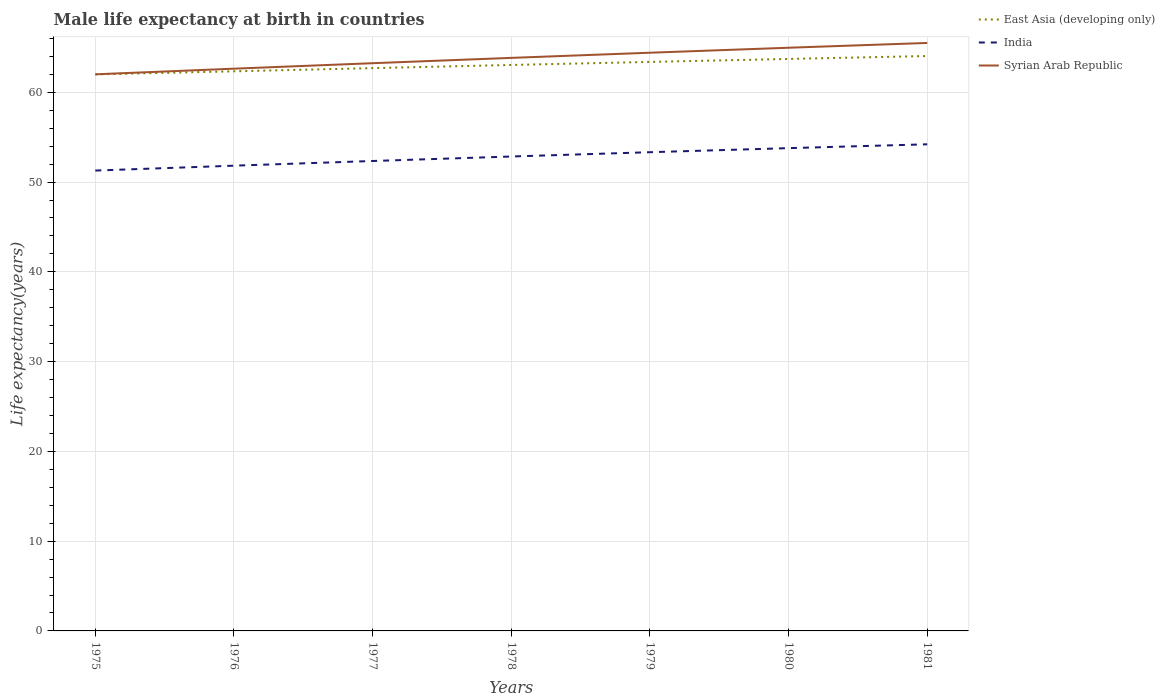How many different coloured lines are there?
Your answer should be compact. 3. Is the number of lines equal to the number of legend labels?
Provide a succinct answer. Yes. Across all years, what is the maximum male life expectancy at birth in India?
Your answer should be very brief. 51.28. In which year was the male life expectancy at birth in Syrian Arab Republic maximum?
Make the answer very short. 1975. What is the total male life expectancy at birth in Syrian Arab Republic in the graph?
Provide a succinct answer. -0.59. What is the difference between the highest and the second highest male life expectancy at birth in Syrian Arab Republic?
Your answer should be very brief. 3.49. Is the male life expectancy at birth in Syrian Arab Republic strictly greater than the male life expectancy at birth in India over the years?
Give a very brief answer. No. Are the values on the major ticks of Y-axis written in scientific E-notation?
Offer a very short reply. No. How many legend labels are there?
Give a very brief answer. 3. How are the legend labels stacked?
Your answer should be compact. Vertical. What is the title of the graph?
Ensure brevity in your answer.  Male life expectancy at birth in countries. Does "World" appear as one of the legend labels in the graph?
Provide a short and direct response. No. What is the label or title of the Y-axis?
Provide a short and direct response. Life expectancy(years). What is the Life expectancy(years) of East Asia (developing only) in 1975?
Your answer should be compact. 62. What is the Life expectancy(years) in India in 1975?
Provide a succinct answer. 51.28. What is the Life expectancy(years) of Syrian Arab Republic in 1975?
Offer a very short reply. 62.01. What is the Life expectancy(years) in East Asia (developing only) in 1976?
Keep it short and to the point. 62.34. What is the Life expectancy(years) of India in 1976?
Keep it short and to the point. 51.83. What is the Life expectancy(years) of Syrian Arab Republic in 1976?
Offer a very short reply. 62.63. What is the Life expectancy(years) in East Asia (developing only) in 1977?
Offer a terse response. 62.7. What is the Life expectancy(years) in India in 1977?
Provide a short and direct response. 52.35. What is the Life expectancy(years) in Syrian Arab Republic in 1977?
Ensure brevity in your answer.  63.24. What is the Life expectancy(years) of East Asia (developing only) in 1978?
Your answer should be compact. 63.05. What is the Life expectancy(years) in India in 1978?
Offer a terse response. 52.85. What is the Life expectancy(years) of Syrian Arab Republic in 1978?
Provide a short and direct response. 63.84. What is the Life expectancy(years) in East Asia (developing only) in 1979?
Your answer should be very brief. 63.39. What is the Life expectancy(years) in India in 1979?
Make the answer very short. 53.33. What is the Life expectancy(years) in Syrian Arab Republic in 1979?
Offer a terse response. 64.41. What is the Life expectancy(years) in East Asia (developing only) in 1980?
Make the answer very short. 63.72. What is the Life expectancy(years) of India in 1980?
Provide a succinct answer. 53.78. What is the Life expectancy(years) in Syrian Arab Republic in 1980?
Offer a terse response. 64.97. What is the Life expectancy(years) in East Asia (developing only) in 1981?
Your answer should be very brief. 64.04. What is the Life expectancy(years) in India in 1981?
Your response must be concise. 54.21. What is the Life expectancy(years) of Syrian Arab Republic in 1981?
Your answer should be very brief. 65.5. Across all years, what is the maximum Life expectancy(years) in East Asia (developing only)?
Your answer should be very brief. 64.04. Across all years, what is the maximum Life expectancy(years) in India?
Your answer should be very brief. 54.21. Across all years, what is the maximum Life expectancy(years) of Syrian Arab Republic?
Offer a very short reply. 65.5. Across all years, what is the minimum Life expectancy(years) of East Asia (developing only)?
Provide a succinct answer. 62. Across all years, what is the minimum Life expectancy(years) in India?
Give a very brief answer. 51.28. Across all years, what is the minimum Life expectancy(years) of Syrian Arab Republic?
Offer a very short reply. 62.01. What is the total Life expectancy(years) of East Asia (developing only) in the graph?
Your answer should be compact. 441.23. What is the total Life expectancy(years) in India in the graph?
Offer a terse response. 369.63. What is the total Life expectancy(years) of Syrian Arab Republic in the graph?
Make the answer very short. 446.6. What is the difference between the Life expectancy(years) in East Asia (developing only) in 1975 and that in 1976?
Offer a terse response. -0.34. What is the difference between the Life expectancy(years) in India in 1975 and that in 1976?
Offer a terse response. -0.54. What is the difference between the Life expectancy(years) of Syrian Arab Republic in 1975 and that in 1976?
Your response must be concise. -0.63. What is the difference between the Life expectancy(years) in East Asia (developing only) in 1975 and that in 1977?
Provide a short and direct response. -0.7. What is the difference between the Life expectancy(years) of India in 1975 and that in 1977?
Your answer should be compact. -1.06. What is the difference between the Life expectancy(years) of Syrian Arab Republic in 1975 and that in 1977?
Offer a very short reply. -1.24. What is the difference between the Life expectancy(years) of East Asia (developing only) in 1975 and that in 1978?
Your answer should be very brief. -1.05. What is the difference between the Life expectancy(years) in India in 1975 and that in 1978?
Give a very brief answer. -1.56. What is the difference between the Life expectancy(years) in Syrian Arab Republic in 1975 and that in 1978?
Your answer should be very brief. -1.83. What is the difference between the Life expectancy(years) in East Asia (developing only) in 1975 and that in 1979?
Offer a terse response. -1.39. What is the difference between the Life expectancy(years) of India in 1975 and that in 1979?
Your answer should be very brief. -2.04. What is the difference between the Life expectancy(years) of Syrian Arab Republic in 1975 and that in 1979?
Ensure brevity in your answer.  -2.41. What is the difference between the Life expectancy(years) of East Asia (developing only) in 1975 and that in 1980?
Offer a very short reply. -1.72. What is the difference between the Life expectancy(years) in India in 1975 and that in 1980?
Give a very brief answer. -2.5. What is the difference between the Life expectancy(years) of Syrian Arab Republic in 1975 and that in 1980?
Offer a very short reply. -2.96. What is the difference between the Life expectancy(years) in East Asia (developing only) in 1975 and that in 1981?
Make the answer very short. -2.05. What is the difference between the Life expectancy(years) in India in 1975 and that in 1981?
Offer a terse response. -2.92. What is the difference between the Life expectancy(years) in Syrian Arab Republic in 1975 and that in 1981?
Your response must be concise. -3.49. What is the difference between the Life expectancy(years) in East Asia (developing only) in 1976 and that in 1977?
Give a very brief answer. -0.36. What is the difference between the Life expectancy(years) in India in 1976 and that in 1977?
Your answer should be very brief. -0.52. What is the difference between the Life expectancy(years) of Syrian Arab Republic in 1976 and that in 1977?
Keep it short and to the point. -0.61. What is the difference between the Life expectancy(years) of East Asia (developing only) in 1976 and that in 1978?
Your response must be concise. -0.71. What is the difference between the Life expectancy(years) of India in 1976 and that in 1978?
Your answer should be very brief. -1.02. What is the difference between the Life expectancy(years) of Syrian Arab Republic in 1976 and that in 1978?
Provide a succinct answer. -1.2. What is the difference between the Life expectancy(years) in East Asia (developing only) in 1976 and that in 1979?
Make the answer very short. -1.05. What is the difference between the Life expectancy(years) in India in 1976 and that in 1979?
Make the answer very short. -1.5. What is the difference between the Life expectancy(years) of Syrian Arab Republic in 1976 and that in 1979?
Provide a short and direct response. -1.78. What is the difference between the Life expectancy(years) in East Asia (developing only) in 1976 and that in 1980?
Make the answer very short. -1.38. What is the difference between the Life expectancy(years) of India in 1976 and that in 1980?
Give a very brief answer. -1.96. What is the difference between the Life expectancy(years) in Syrian Arab Republic in 1976 and that in 1980?
Provide a succinct answer. -2.33. What is the difference between the Life expectancy(years) in East Asia (developing only) in 1976 and that in 1981?
Offer a very short reply. -1.7. What is the difference between the Life expectancy(years) of India in 1976 and that in 1981?
Your answer should be compact. -2.38. What is the difference between the Life expectancy(years) of Syrian Arab Republic in 1976 and that in 1981?
Offer a terse response. -2.87. What is the difference between the Life expectancy(years) of East Asia (developing only) in 1977 and that in 1978?
Your answer should be compact. -0.35. What is the difference between the Life expectancy(years) of India in 1977 and that in 1978?
Give a very brief answer. -0.5. What is the difference between the Life expectancy(years) of Syrian Arab Republic in 1977 and that in 1978?
Your response must be concise. -0.59. What is the difference between the Life expectancy(years) of East Asia (developing only) in 1977 and that in 1979?
Keep it short and to the point. -0.69. What is the difference between the Life expectancy(years) in India in 1977 and that in 1979?
Provide a short and direct response. -0.98. What is the difference between the Life expectancy(years) of Syrian Arab Republic in 1977 and that in 1979?
Your response must be concise. -1.17. What is the difference between the Life expectancy(years) of East Asia (developing only) in 1977 and that in 1980?
Your answer should be compact. -1.02. What is the difference between the Life expectancy(years) of India in 1977 and that in 1980?
Give a very brief answer. -1.43. What is the difference between the Life expectancy(years) in Syrian Arab Republic in 1977 and that in 1980?
Provide a succinct answer. -1.72. What is the difference between the Life expectancy(years) of East Asia (developing only) in 1977 and that in 1981?
Offer a terse response. -1.35. What is the difference between the Life expectancy(years) of India in 1977 and that in 1981?
Your answer should be very brief. -1.86. What is the difference between the Life expectancy(years) of Syrian Arab Republic in 1977 and that in 1981?
Offer a terse response. -2.26. What is the difference between the Life expectancy(years) in East Asia (developing only) in 1978 and that in 1979?
Give a very brief answer. -0.34. What is the difference between the Life expectancy(years) in India in 1978 and that in 1979?
Give a very brief answer. -0.48. What is the difference between the Life expectancy(years) in Syrian Arab Republic in 1978 and that in 1979?
Make the answer very short. -0.57. What is the difference between the Life expectancy(years) of East Asia (developing only) in 1978 and that in 1980?
Your answer should be very brief. -0.67. What is the difference between the Life expectancy(years) in India in 1978 and that in 1980?
Keep it short and to the point. -0.93. What is the difference between the Life expectancy(years) of Syrian Arab Republic in 1978 and that in 1980?
Offer a very short reply. -1.13. What is the difference between the Life expectancy(years) in East Asia (developing only) in 1978 and that in 1981?
Offer a very short reply. -1. What is the difference between the Life expectancy(years) of India in 1978 and that in 1981?
Your answer should be compact. -1.36. What is the difference between the Life expectancy(years) in Syrian Arab Republic in 1978 and that in 1981?
Offer a very short reply. -1.66. What is the difference between the Life expectancy(years) of East Asia (developing only) in 1979 and that in 1980?
Give a very brief answer. -0.33. What is the difference between the Life expectancy(years) of India in 1979 and that in 1980?
Your answer should be compact. -0.45. What is the difference between the Life expectancy(years) in Syrian Arab Republic in 1979 and that in 1980?
Make the answer very short. -0.56. What is the difference between the Life expectancy(years) of East Asia (developing only) in 1979 and that in 1981?
Your answer should be compact. -0.66. What is the difference between the Life expectancy(years) of India in 1979 and that in 1981?
Provide a succinct answer. -0.88. What is the difference between the Life expectancy(years) of Syrian Arab Republic in 1979 and that in 1981?
Ensure brevity in your answer.  -1.09. What is the difference between the Life expectancy(years) in East Asia (developing only) in 1980 and that in 1981?
Provide a succinct answer. -0.32. What is the difference between the Life expectancy(years) in India in 1980 and that in 1981?
Your response must be concise. -0.43. What is the difference between the Life expectancy(years) of Syrian Arab Republic in 1980 and that in 1981?
Provide a succinct answer. -0.53. What is the difference between the Life expectancy(years) of East Asia (developing only) in 1975 and the Life expectancy(years) of India in 1976?
Your answer should be very brief. 10.17. What is the difference between the Life expectancy(years) of East Asia (developing only) in 1975 and the Life expectancy(years) of Syrian Arab Republic in 1976?
Provide a short and direct response. -0.64. What is the difference between the Life expectancy(years) in India in 1975 and the Life expectancy(years) in Syrian Arab Republic in 1976?
Keep it short and to the point. -11.35. What is the difference between the Life expectancy(years) in East Asia (developing only) in 1975 and the Life expectancy(years) in India in 1977?
Make the answer very short. 9.65. What is the difference between the Life expectancy(years) in East Asia (developing only) in 1975 and the Life expectancy(years) in Syrian Arab Republic in 1977?
Provide a short and direct response. -1.25. What is the difference between the Life expectancy(years) of India in 1975 and the Life expectancy(years) of Syrian Arab Republic in 1977?
Your response must be concise. -11.96. What is the difference between the Life expectancy(years) of East Asia (developing only) in 1975 and the Life expectancy(years) of India in 1978?
Give a very brief answer. 9.15. What is the difference between the Life expectancy(years) of East Asia (developing only) in 1975 and the Life expectancy(years) of Syrian Arab Republic in 1978?
Your answer should be very brief. -1.84. What is the difference between the Life expectancy(years) in India in 1975 and the Life expectancy(years) in Syrian Arab Republic in 1978?
Your answer should be very brief. -12.55. What is the difference between the Life expectancy(years) in East Asia (developing only) in 1975 and the Life expectancy(years) in India in 1979?
Provide a succinct answer. 8.67. What is the difference between the Life expectancy(years) in East Asia (developing only) in 1975 and the Life expectancy(years) in Syrian Arab Republic in 1979?
Give a very brief answer. -2.42. What is the difference between the Life expectancy(years) in India in 1975 and the Life expectancy(years) in Syrian Arab Republic in 1979?
Your answer should be very brief. -13.13. What is the difference between the Life expectancy(years) in East Asia (developing only) in 1975 and the Life expectancy(years) in India in 1980?
Provide a short and direct response. 8.21. What is the difference between the Life expectancy(years) of East Asia (developing only) in 1975 and the Life expectancy(years) of Syrian Arab Republic in 1980?
Your response must be concise. -2.97. What is the difference between the Life expectancy(years) in India in 1975 and the Life expectancy(years) in Syrian Arab Republic in 1980?
Your answer should be compact. -13.68. What is the difference between the Life expectancy(years) of East Asia (developing only) in 1975 and the Life expectancy(years) of India in 1981?
Your answer should be compact. 7.79. What is the difference between the Life expectancy(years) of East Asia (developing only) in 1975 and the Life expectancy(years) of Syrian Arab Republic in 1981?
Offer a terse response. -3.5. What is the difference between the Life expectancy(years) in India in 1975 and the Life expectancy(years) in Syrian Arab Republic in 1981?
Your response must be concise. -14.21. What is the difference between the Life expectancy(years) of East Asia (developing only) in 1976 and the Life expectancy(years) of India in 1977?
Offer a very short reply. 9.99. What is the difference between the Life expectancy(years) of East Asia (developing only) in 1976 and the Life expectancy(years) of Syrian Arab Republic in 1977?
Keep it short and to the point. -0.9. What is the difference between the Life expectancy(years) of India in 1976 and the Life expectancy(years) of Syrian Arab Republic in 1977?
Your answer should be compact. -11.42. What is the difference between the Life expectancy(years) in East Asia (developing only) in 1976 and the Life expectancy(years) in India in 1978?
Ensure brevity in your answer.  9.49. What is the difference between the Life expectancy(years) in East Asia (developing only) in 1976 and the Life expectancy(years) in Syrian Arab Republic in 1978?
Ensure brevity in your answer.  -1.5. What is the difference between the Life expectancy(years) in India in 1976 and the Life expectancy(years) in Syrian Arab Republic in 1978?
Your response must be concise. -12.01. What is the difference between the Life expectancy(years) of East Asia (developing only) in 1976 and the Life expectancy(years) of India in 1979?
Make the answer very short. 9.01. What is the difference between the Life expectancy(years) in East Asia (developing only) in 1976 and the Life expectancy(years) in Syrian Arab Republic in 1979?
Keep it short and to the point. -2.07. What is the difference between the Life expectancy(years) in India in 1976 and the Life expectancy(years) in Syrian Arab Republic in 1979?
Keep it short and to the point. -12.59. What is the difference between the Life expectancy(years) in East Asia (developing only) in 1976 and the Life expectancy(years) in India in 1980?
Make the answer very short. 8.56. What is the difference between the Life expectancy(years) in East Asia (developing only) in 1976 and the Life expectancy(years) in Syrian Arab Republic in 1980?
Ensure brevity in your answer.  -2.63. What is the difference between the Life expectancy(years) of India in 1976 and the Life expectancy(years) of Syrian Arab Republic in 1980?
Offer a very short reply. -13.14. What is the difference between the Life expectancy(years) in East Asia (developing only) in 1976 and the Life expectancy(years) in India in 1981?
Offer a very short reply. 8.13. What is the difference between the Life expectancy(years) in East Asia (developing only) in 1976 and the Life expectancy(years) in Syrian Arab Republic in 1981?
Your answer should be very brief. -3.16. What is the difference between the Life expectancy(years) of India in 1976 and the Life expectancy(years) of Syrian Arab Republic in 1981?
Offer a very short reply. -13.67. What is the difference between the Life expectancy(years) in East Asia (developing only) in 1977 and the Life expectancy(years) in India in 1978?
Your answer should be compact. 9.85. What is the difference between the Life expectancy(years) of East Asia (developing only) in 1977 and the Life expectancy(years) of Syrian Arab Republic in 1978?
Make the answer very short. -1.14. What is the difference between the Life expectancy(years) of India in 1977 and the Life expectancy(years) of Syrian Arab Republic in 1978?
Offer a terse response. -11.49. What is the difference between the Life expectancy(years) of East Asia (developing only) in 1977 and the Life expectancy(years) of India in 1979?
Ensure brevity in your answer.  9.37. What is the difference between the Life expectancy(years) in East Asia (developing only) in 1977 and the Life expectancy(years) in Syrian Arab Republic in 1979?
Keep it short and to the point. -1.72. What is the difference between the Life expectancy(years) in India in 1977 and the Life expectancy(years) in Syrian Arab Republic in 1979?
Keep it short and to the point. -12.06. What is the difference between the Life expectancy(years) of East Asia (developing only) in 1977 and the Life expectancy(years) of India in 1980?
Ensure brevity in your answer.  8.91. What is the difference between the Life expectancy(years) in East Asia (developing only) in 1977 and the Life expectancy(years) in Syrian Arab Republic in 1980?
Offer a terse response. -2.27. What is the difference between the Life expectancy(years) in India in 1977 and the Life expectancy(years) in Syrian Arab Republic in 1980?
Your response must be concise. -12.62. What is the difference between the Life expectancy(years) in East Asia (developing only) in 1977 and the Life expectancy(years) in India in 1981?
Provide a short and direct response. 8.49. What is the difference between the Life expectancy(years) of East Asia (developing only) in 1977 and the Life expectancy(years) of Syrian Arab Republic in 1981?
Give a very brief answer. -2.8. What is the difference between the Life expectancy(years) of India in 1977 and the Life expectancy(years) of Syrian Arab Republic in 1981?
Offer a very short reply. -13.15. What is the difference between the Life expectancy(years) of East Asia (developing only) in 1978 and the Life expectancy(years) of India in 1979?
Your answer should be very brief. 9.72. What is the difference between the Life expectancy(years) in East Asia (developing only) in 1978 and the Life expectancy(years) in Syrian Arab Republic in 1979?
Offer a terse response. -1.37. What is the difference between the Life expectancy(years) in India in 1978 and the Life expectancy(years) in Syrian Arab Republic in 1979?
Keep it short and to the point. -11.56. What is the difference between the Life expectancy(years) in East Asia (developing only) in 1978 and the Life expectancy(years) in India in 1980?
Provide a succinct answer. 9.26. What is the difference between the Life expectancy(years) of East Asia (developing only) in 1978 and the Life expectancy(years) of Syrian Arab Republic in 1980?
Your response must be concise. -1.92. What is the difference between the Life expectancy(years) of India in 1978 and the Life expectancy(years) of Syrian Arab Republic in 1980?
Provide a short and direct response. -12.12. What is the difference between the Life expectancy(years) of East Asia (developing only) in 1978 and the Life expectancy(years) of India in 1981?
Your response must be concise. 8.84. What is the difference between the Life expectancy(years) in East Asia (developing only) in 1978 and the Life expectancy(years) in Syrian Arab Republic in 1981?
Offer a terse response. -2.45. What is the difference between the Life expectancy(years) in India in 1978 and the Life expectancy(years) in Syrian Arab Republic in 1981?
Provide a short and direct response. -12.65. What is the difference between the Life expectancy(years) in East Asia (developing only) in 1979 and the Life expectancy(years) in India in 1980?
Make the answer very short. 9.6. What is the difference between the Life expectancy(years) of East Asia (developing only) in 1979 and the Life expectancy(years) of Syrian Arab Republic in 1980?
Offer a very short reply. -1.58. What is the difference between the Life expectancy(years) of India in 1979 and the Life expectancy(years) of Syrian Arab Republic in 1980?
Keep it short and to the point. -11.64. What is the difference between the Life expectancy(years) of East Asia (developing only) in 1979 and the Life expectancy(years) of India in 1981?
Make the answer very short. 9.18. What is the difference between the Life expectancy(years) of East Asia (developing only) in 1979 and the Life expectancy(years) of Syrian Arab Republic in 1981?
Make the answer very short. -2.11. What is the difference between the Life expectancy(years) of India in 1979 and the Life expectancy(years) of Syrian Arab Republic in 1981?
Provide a short and direct response. -12.17. What is the difference between the Life expectancy(years) of East Asia (developing only) in 1980 and the Life expectancy(years) of India in 1981?
Provide a succinct answer. 9.51. What is the difference between the Life expectancy(years) of East Asia (developing only) in 1980 and the Life expectancy(years) of Syrian Arab Republic in 1981?
Your answer should be compact. -1.78. What is the difference between the Life expectancy(years) in India in 1980 and the Life expectancy(years) in Syrian Arab Republic in 1981?
Provide a short and direct response. -11.72. What is the average Life expectancy(years) of East Asia (developing only) per year?
Your answer should be very brief. 63.03. What is the average Life expectancy(years) of India per year?
Keep it short and to the point. 52.8. What is the average Life expectancy(years) in Syrian Arab Republic per year?
Provide a short and direct response. 63.8. In the year 1975, what is the difference between the Life expectancy(years) in East Asia (developing only) and Life expectancy(years) in India?
Provide a succinct answer. 10.71. In the year 1975, what is the difference between the Life expectancy(years) in East Asia (developing only) and Life expectancy(years) in Syrian Arab Republic?
Offer a terse response. -0.01. In the year 1975, what is the difference between the Life expectancy(years) in India and Life expectancy(years) in Syrian Arab Republic?
Keep it short and to the point. -10.72. In the year 1976, what is the difference between the Life expectancy(years) in East Asia (developing only) and Life expectancy(years) in India?
Your response must be concise. 10.51. In the year 1976, what is the difference between the Life expectancy(years) in East Asia (developing only) and Life expectancy(years) in Syrian Arab Republic?
Provide a short and direct response. -0.29. In the year 1976, what is the difference between the Life expectancy(years) of India and Life expectancy(years) of Syrian Arab Republic?
Keep it short and to the point. -10.81. In the year 1977, what is the difference between the Life expectancy(years) in East Asia (developing only) and Life expectancy(years) in India?
Your answer should be very brief. 10.35. In the year 1977, what is the difference between the Life expectancy(years) of East Asia (developing only) and Life expectancy(years) of Syrian Arab Republic?
Provide a succinct answer. -0.55. In the year 1977, what is the difference between the Life expectancy(years) of India and Life expectancy(years) of Syrian Arab Republic?
Offer a very short reply. -10.89. In the year 1978, what is the difference between the Life expectancy(years) in East Asia (developing only) and Life expectancy(years) in India?
Give a very brief answer. 10.2. In the year 1978, what is the difference between the Life expectancy(years) of East Asia (developing only) and Life expectancy(years) of Syrian Arab Republic?
Give a very brief answer. -0.79. In the year 1978, what is the difference between the Life expectancy(years) of India and Life expectancy(years) of Syrian Arab Republic?
Make the answer very short. -10.99. In the year 1979, what is the difference between the Life expectancy(years) in East Asia (developing only) and Life expectancy(years) in India?
Make the answer very short. 10.06. In the year 1979, what is the difference between the Life expectancy(years) of East Asia (developing only) and Life expectancy(years) of Syrian Arab Republic?
Provide a succinct answer. -1.03. In the year 1979, what is the difference between the Life expectancy(years) of India and Life expectancy(years) of Syrian Arab Republic?
Ensure brevity in your answer.  -11.08. In the year 1980, what is the difference between the Life expectancy(years) in East Asia (developing only) and Life expectancy(years) in India?
Your answer should be very brief. 9.94. In the year 1980, what is the difference between the Life expectancy(years) in East Asia (developing only) and Life expectancy(years) in Syrian Arab Republic?
Keep it short and to the point. -1.25. In the year 1980, what is the difference between the Life expectancy(years) of India and Life expectancy(years) of Syrian Arab Republic?
Ensure brevity in your answer.  -11.19. In the year 1981, what is the difference between the Life expectancy(years) in East Asia (developing only) and Life expectancy(years) in India?
Ensure brevity in your answer.  9.83. In the year 1981, what is the difference between the Life expectancy(years) of East Asia (developing only) and Life expectancy(years) of Syrian Arab Republic?
Your response must be concise. -1.46. In the year 1981, what is the difference between the Life expectancy(years) of India and Life expectancy(years) of Syrian Arab Republic?
Make the answer very short. -11.29. What is the ratio of the Life expectancy(years) of East Asia (developing only) in 1975 to that in 1977?
Provide a short and direct response. 0.99. What is the ratio of the Life expectancy(years) in India in 1975 to that in 1977?
Ensure brevity in your answer.  0.98. What is the ratio of the Life expectancy(years) of Syrian Arab Republic in 1975 to that in 1977?
Provide a succinct answer. 0.98. What is the ratio of the Life expectancy(years) in East Asia (developing only) in 1975 to that in 1978?
Offer a very short reply. 0.98. What is the ratio of the Life expectancy(years) of India in 1975 to that in 1978?
Give a very brief answer. 0.97. What is the ratio of the Life expectancy(years) of Syrian Arab Republic in 1975 to that in 1978?
Your response must be concise. 0.97. What is the ratio of the Life expectancy(years) in East Asia (developing only) in 1975 to that in 1979?
Provide a short and direct response. 0.98. What is the ratio of the Life expectancy(years) of India in 1975 to that in 1979?
Offer a terse response. 0.96. What is the ratio of the Life expectancy(years) in Syrian Arab Republic in 1975 to that in 1979?
Give a very brief answer. 0.96. What is the ratio of the Life expectancy(years) in India in 1975 to that in 1980?
Make the answer very short. 0.95. What is the ratio of the Life expectancy(years) in Syrian Arab Republic in 1975 to that in 1980?
Your response must be concise. 0.95. What is the ratio of the Life expectancy(years) of East Asia (developing only) in 1975 to that in 1981?
Your answer should be very brief. 0.97. What is the ratio of the Life expectancy(years) in India in 1975 to that in 1981?
Provide a short and direct response. 0.95. What is the ratio of the Life expectancy(years) in Syrian Arab Republic in 1975 to that in 1981?
Ensure brevity in your answer.  0.95. What is the ratio of the Life expectancy(years) in East Asia (developing only) in 1976 to that in 1977?
Your answer should be very brief. 0.99. What is the ratio of the Life expectancy(years) of India in 1976 to that in 1977?
Offer a terse response. 0.99. What is the ratio of the Life expectancy(years) in East Asia (developing only) in 1976 to that in 1978?
Keep it short and to the point. 0.99. What is the ratio of the Life expectancy(years) in India in 1976 to that in 1978?
Your response must be concise. 0.98. What is the ratio of the Life expectancy(years) of Syrian Arab Republic in 1976 to that in 1978?
Offer a very short reply. 0.98. What is the ratio of the Life expectancy(years) of East Asia (developing only) in 1976 to that in 1979?
Offer a terse response. 0.98. What is the ratio of the Life expectancy(years) of India in 1976 to that in 1979?
Offer a terse response. 0.97. What is the ratio of the Life expectancy(years) of Syrian Arab Republic in 1976 to that in 1979?
Ensure brevity in your answer.  0.97. What is the ratio of the Life expectancy(years) in East Asia (developing only) in 1976 to that in 1980?
Offer a very short reply. 0.98. What is the ratio of the Life expectancy(years) in India in 1976 to that in 1980?
Provide a short and direct response. 0.96. What is the ratio of the Life expectancy(years) in Syrian Arab Republic in 1976 to that in 1980?
Your answer should be very brief. 0.96. What is the ratio of the Life expectancy(years) of East Asia (developing only) in 1976 to that in 1981?
Ensure brevity in your answer.  0.97. What is the ratio of the Life expectancy(years) in India in 1976 to that in 1981?
Provide a short and direct response. 0.96. What is the ratio of the Life expectancy(years) in Syrian Arab Republic in 1976 to that in 1981?
Give a very brief answer. 0.96. What is the ratio of the Life expectancy(years) of East Asia (developing only) in 1977 to that in 1979?
Offer a terse response. 0.99. What is the ratio of the Life expectancy(years) of India in 1977 to that in 1979?
Offer a terse response. 0.98. What is the ratio of the Life expectancy(years) in Syrian Arab Republic in 1977 to that in 1979?
Your answer should be compact. 0.98. What is the ratio of the Life expectancy(years) of India in 1977 to that in 1980?
Your answer should be compact. 0.97. What is the ratio of the Life expectancy(years) in Syrian Arab Republic in 1977 to that in 1980?
Give a very brief answer. 0.97. What is the ratio of the Life expectancy(years) in East Asia (developing only) in 1977 to that in 1981?
Your answer should be compact. 0.98. What is the ratio of the Life expectancy(years) of India in 1977 to that in 1981?
Ensure brevity in your answer.  0.97. What is the ratio of the Life expectancy(years) in Syrian Arab Republic in 1977 to that in 1981?
Your answer should be very brief. 0.97. What is the ratio of the Life expectancy(years) of East Asia (developing only) in 1978 to that in 1979?
Offer a very short reply. 0.99. What is the ratio of the Life expectancy(years) in India in 1978 to that in 1980?
Ensure brevity in your answer.  0.98. What is the ratio of the Life expectancy(years) of Syrian Arab Republic in 1978 to that in 1980?
Offer a very short reply. 0.98. What is the ratio of the Life expectancy(years) in East Asia (developing only) in 1978 to that in 1981?
Offer a very short reply. 0.98. What is the ratio of the Life expectancy(years) of India in 1978 to that in 1981?
Make the answer very short. 0.97. What is the ratio of the Life expectancy(years) in Syrian Arab Republic in 1978 to that in 1981?
Your response must be concise. 0.97. What is the ratio of the Life expectancy(years) in East Asia (developing only) in 1979 to that in 1980?
Ensure brevity in your answer.  0.99. What is the ratio of the Life expectancy(years) of India in 1979 to that in 1980?
Give a very brief answer. 0.99. What is the ratio of the Life expectancy(years) in India in 1979 to that in 1981?
Your answer should be compact. 0.98. What is the ratio of the Life expectancy(years) in Syrian Arab Republic in 1979 to that in 1981?
Your answer should be compact. 0.98. What is the ratio of the Life expectancy(years) of East Asia (developing only) in 1980 to that in 1981?
Ensure brevity in your answer.  0.99. What is the ratio of the Life expectancy(years) in India in 1980 to that in 1981?
Make the answer very short. 0.99. What is the ratio of the Life expectancy(years) of Syrian Arab Republic in 1980 to that in 1981?
Your answer should be very brief. 0.99. What is the difference between the highest and the second highest Life expectancy(years) of East Asia (developing only)?
Offer a terse response. 0.32. What is the difference between the highest and the second highest Life expectancy(years) in India?
Ensure brevity in your answer.  0.43. What is the difference between the highest and the second highest Life expectancy(years) of Syrian Arab Republic?
Your answer should be compact. 0.53. What is the difference between the highest and the lowest Life expectancy(years) in East Asia (developing only)?
Provide a succinct answer. 2.05. What is the difference between the highest and the lowest Life expectancy(years) in India?
Give a very brief answer. 2.92. What is the difference between the highest and the lowest Life expectancy(years) in Syrian Arab Republic?
Offer a very short reply. 3.49. 